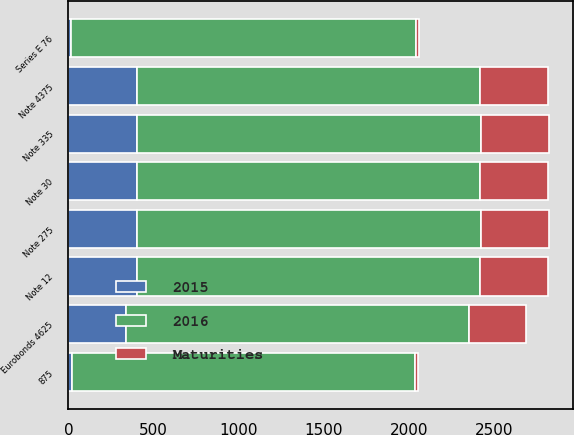Convert chart to OTSL. <chart><loc_0><loc_0><loc_500><loc_500><stacked_bar_chart><ecel><fcel>875<fcel>Series E 76<fcel>Note 12<fcel>Note 4375<fcel>Note 30<fcel>Note 275<fcel>Note 335<fcel>Eurobonds 4625<nl><fcel>2016<fcel>2021<fcel>2026<fcel>2018<fcel>2019<fcel>2022<fcel>2023<fcel>2024<fcel>2017<nl><fcel>2015<fcel>18.4<fcel>17.2<fcel>400<fcel>400<fcel>400<fcel>400<fcel>400<fcel>337<nl><fcel>Maturities<fcel>18.4<fcel>17.2<fcel>400<fcel>400<fcel>400<fcel>400<fcel>400<fcel>335.2<nl></chart> 